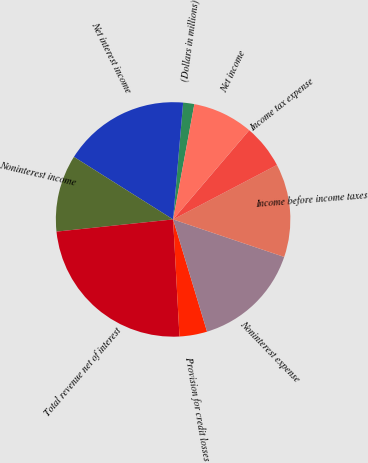<chart> <loc_0><loc_0><loc_500><loc_500><pie_chart><fcel>(Dollars in millions)<fcel>Net interest income<fcel>Noninterest income<fcel>Total revenue net of interest<fcel>Provision for credit losses<fcel>Noninterest expense<fcel>Income before income taxes<fcel>Income tax expense<fcel>Net income<nl><fcel>1.54%<fcel>17.41%<fcel>10.61%<fcel>24.21%<fcel>3.81%<fcel>15.14%<fcel>12.87%<fcel>6.07%<fcel>8.34%<nl></chart> 